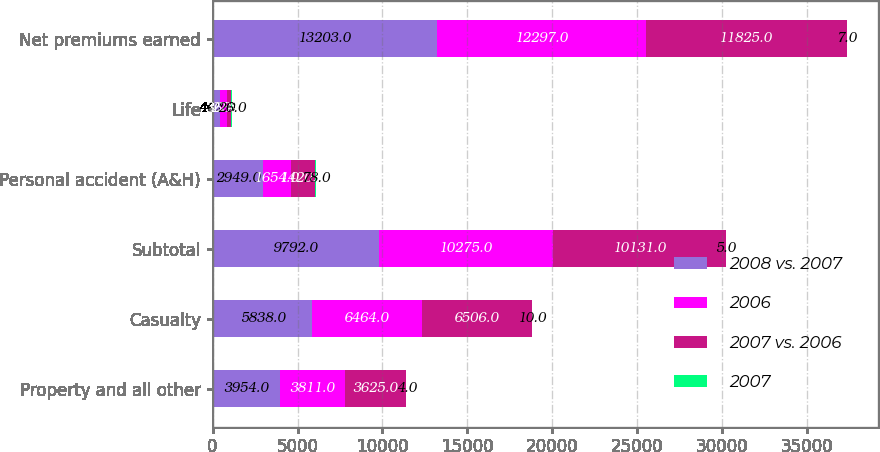Convert chart to OTSL. <chart><loc_0><loc_0><loc_500><loc_500><stacked_bar_chart><ecel><fcel>Property and all other<fcel>Casualty<fcel>Subtotal<fcel>Personal accident (A&H)<fcel>Life<fcel>Net premiums earned<nl><fcel>2008 vs. 2007<fcel>3954<fcel>5838<fcel>9792<fcel>2949<fcel>462<fcel>13203<nl><fcel>2006<fcel>3811<fcel>6464<fcel>10275<fcel>1654<fcel>368<fcel>12297<nl><fcel>2007 vs. 2006<fcel>3625<fcel>6506<fcel>10131<fcel>1420<fcel>274<fcel>11825<nl><fcel>2007<fcel>4<fcel>10<fcel>5<fcel>78<fcel>26<fcel>7<nl></chart> 